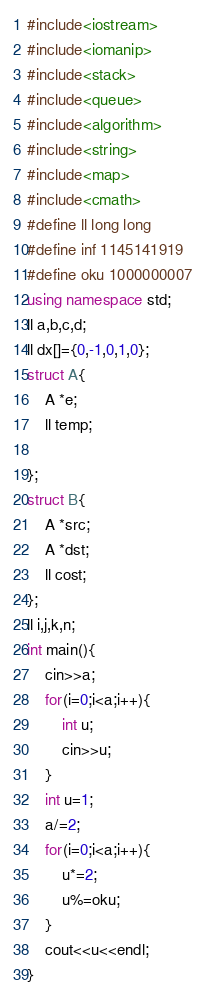Convert code to text. <code><loc_0><loc_0><loc_500><loc_500><_C++_>#include<iostream>
#include<iomanip>
#include<stack>
#include<queue>
#include<algorithm>
#include<string>
#include<map>
#include<cmath>
#define ll long long
#define inf 1145141919
#define oku 1000000007
using namespace std;
ll a,b,c,d;
ll dx[]={0,-1,0,1,0};
struct A{
	A *e;
	ll temp;
	
};
struct B{
	A *src;
	A *dst;
	ll cost;
};
ll i,j,k,n;
int main(){
	cin>>a;
	for(i=0;i<a;i++){
		int u;
		cin>>u;
	}
	int u=1;
	a/=2;
	for(i=0;i<a;i++){
		u*=2;
		u%=oku;
	}
	cout<<u<<endl;
}</code> 